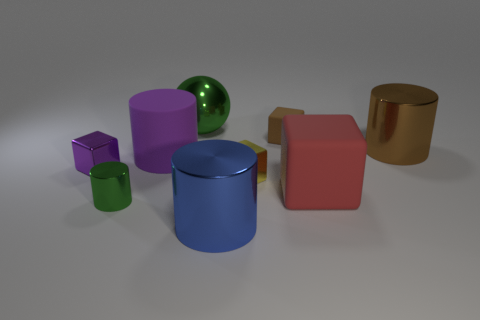Subtract all red rubber cubes. How many cubes are left? 3 Subtract 2 cylinders. How many cylinders are left? 2 Subtract all red blocks. How many blocks are left? 3 Subtract all yellow cylinders. Subtract all blue balls. How many cylinders are left? 4 Subtract all blue cylinders. How many red balls are left? 0 Add 8 small purple things. How many small purple things are left? 9 Add 4 big purple matte cylinders. How many big purple matte cylinders exist? 5 Subtract 1 green spheres. How many objects are left? 8 Subtract all cylinders. How many objects are left? 5 Subtract all big red matte cylinders. Subtract all small yellow blocks. How many objects are left? 8 